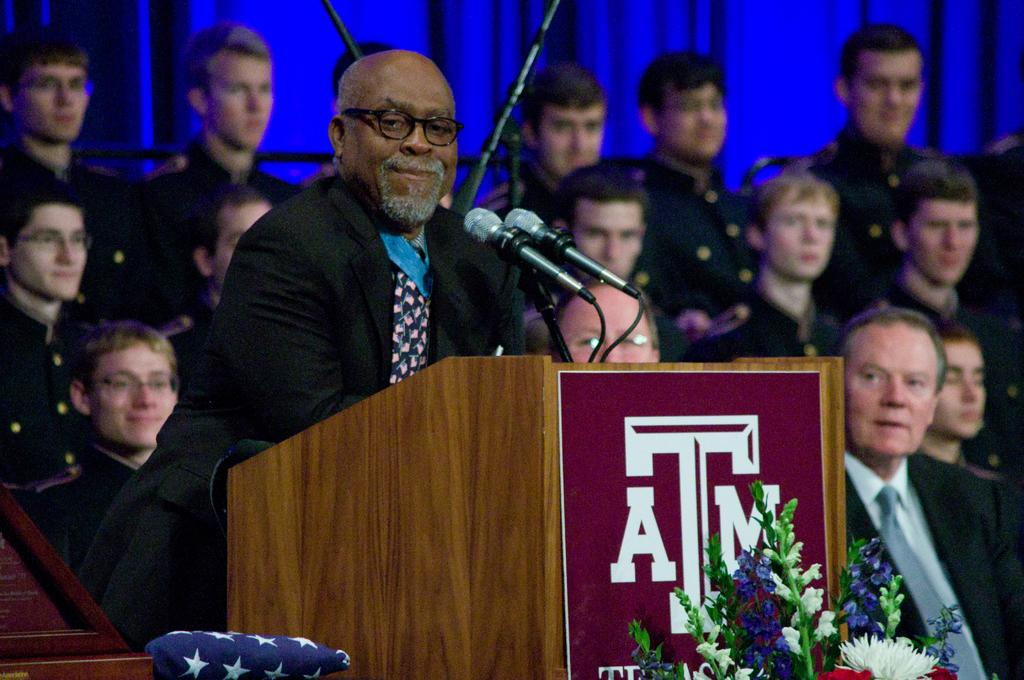How many people are present in the image? There are many people in the image. What is the person near the podium doing? The person is standing near a podium. What object is used for amplifying sound in the image? There is a microphone in the image. What is the bouquet used for in the image? The bouquet is likely used for decoration or as a symbol of appreciation. How much payment is being discussed in the image? There is no mention of payment in the image. What type of grandmother is present in the image? There is no grandmother present in the image. 